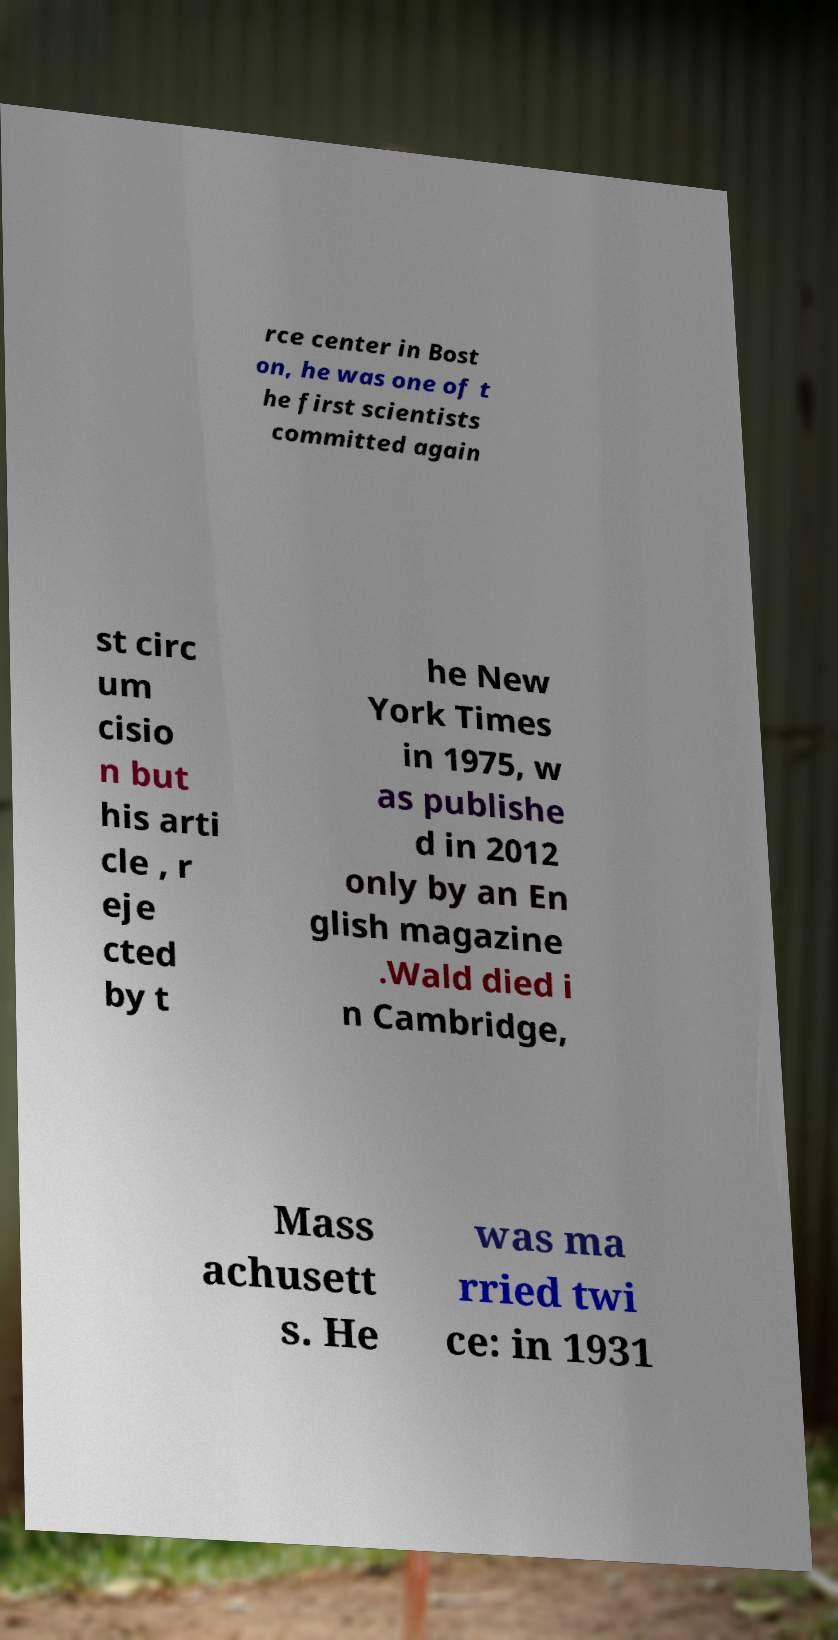For documentation purposes, I need the text within this image transcribed. Could you provide that? rce center in Bost on, he was one of t he first scientists committed again st circ um cisio n but his arti cle , r eje cted by t he New York Times in 1975, w as publishe d in 2012 only by an En glish magazine .Wald died i n Cambridge, Mass achusett s. He was ma rried twi ce: in 1931 